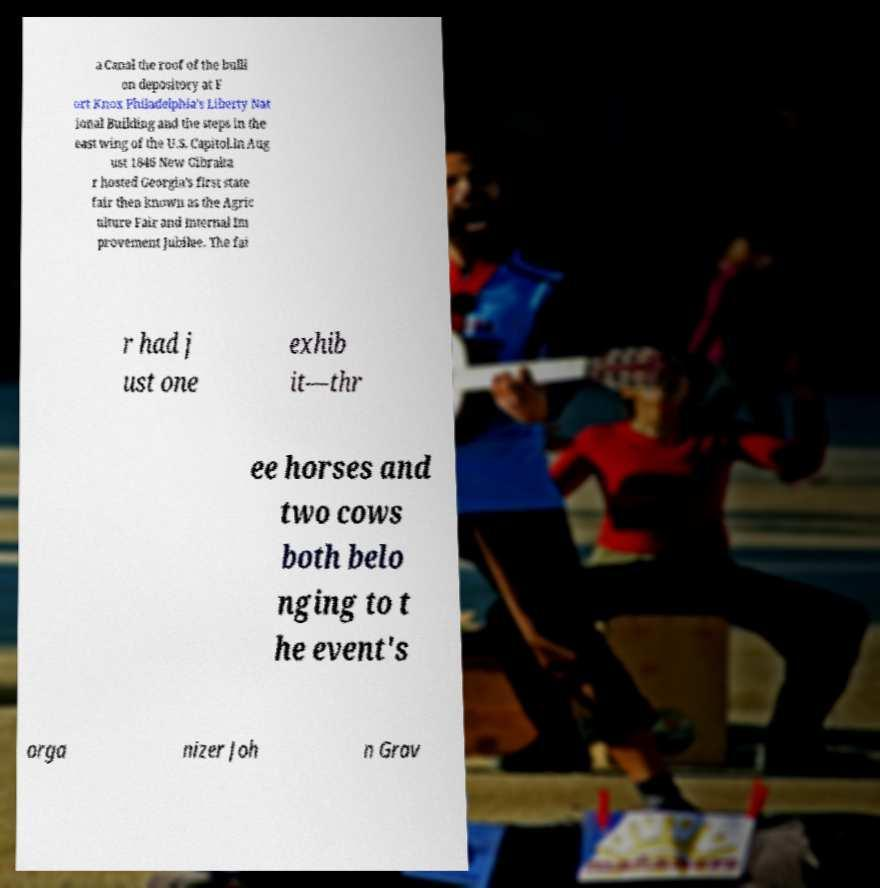Could you assist in decoding the text presented in this image and type it out clearly? a Canal the roof of the bulli on depository at F ort Knox Philadelphia's Liberty Nat ional Building and the steps in the east wing of the U.S. Capitol.In Aug ust 1846 New Gibralta r hosted Georgia's first state fair then known as the Agric ulture Fair and Internal Im provement Jubilee. The fai r had j ust one exhib it—thr ee horses and two cows both belo nging to t he event's orga nizer Joh n Grav 